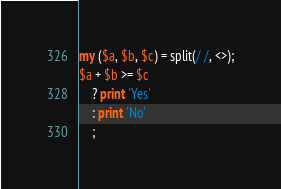<code> <loc_0><loc_0><loc_500><loc_500><_Perl_>my ($a, $b, $c) = split(/ /, <>);
$a + $b >= $c 
    ? print 'Yes'
    : print 'No'
    ;</code> 